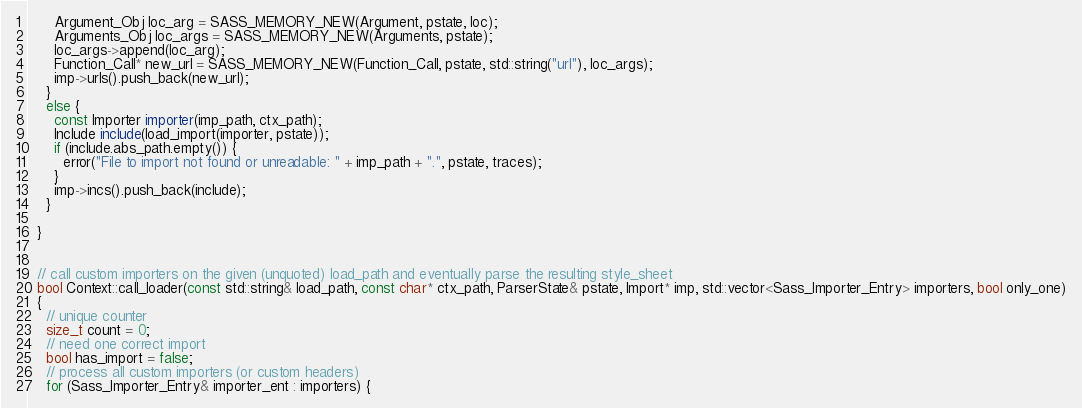Convert code to text. <code><loc_0><loc_0><loc_500><loc_500><_C++_>      Argument_Obj loc_arg = SASS_MEMORY_NEW(Argument, pstate, loc);
      Arguments_Obj loc_args = SASS_MEMORY_NEW(Arguments, pstate);
      loc_args->append(loc_arg);
      Function_Call* new_url = SASS_MEMORY_NEW(Function_Call, pstate, std::string("url"), loc_args);
      imp->urls().push_back(new_url);
    }
    else {
      const Importer importer(imp_path, ctx_path);
      Include include(load_import(importer, pstate));
      if (include.abs_path.empty()) {
        error("File to import not found or unreadable: " + imp_path + ".", pstate, traces);
      }
      imp->incs().push_back(include);
    }

  }


  // call custom importers on the given (unquoted) load_path and eventually parse the resulting style_sheet
  bool Context::call_loader(const std::string& load_path, const char* ctx_path, ParserState& pstate, Import* imp, std::vector<Sass_Importer_Entry> importers, bool only_one)
  {
    // unique counter
    size_t count = 0;
    // need one correct import
    bool has_import = false;
    // process all custom importers (or custom headers)
    for (Sass_Importer_Entry& importer_ent : importers) {</code> 